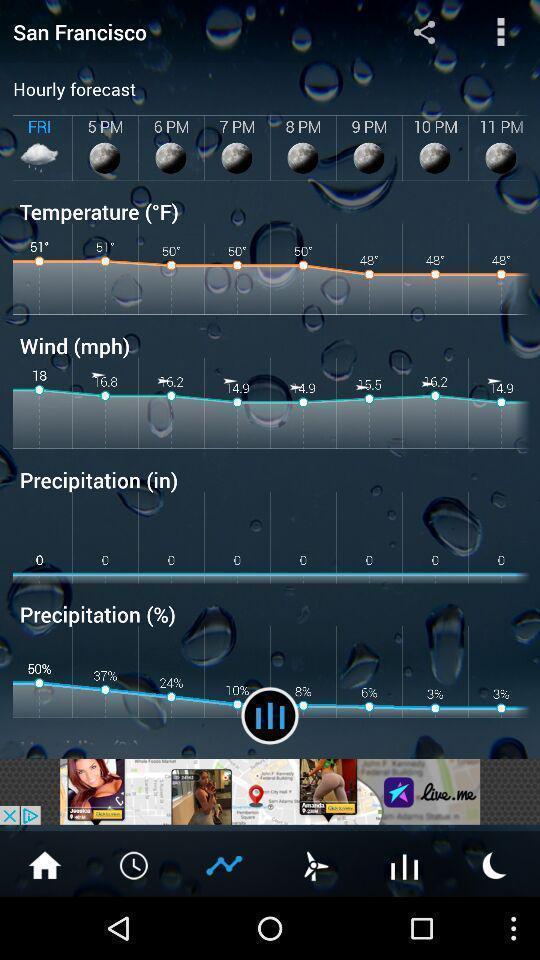Describe the visual elements of this screenshot. Screen displaying the weather forecast. 